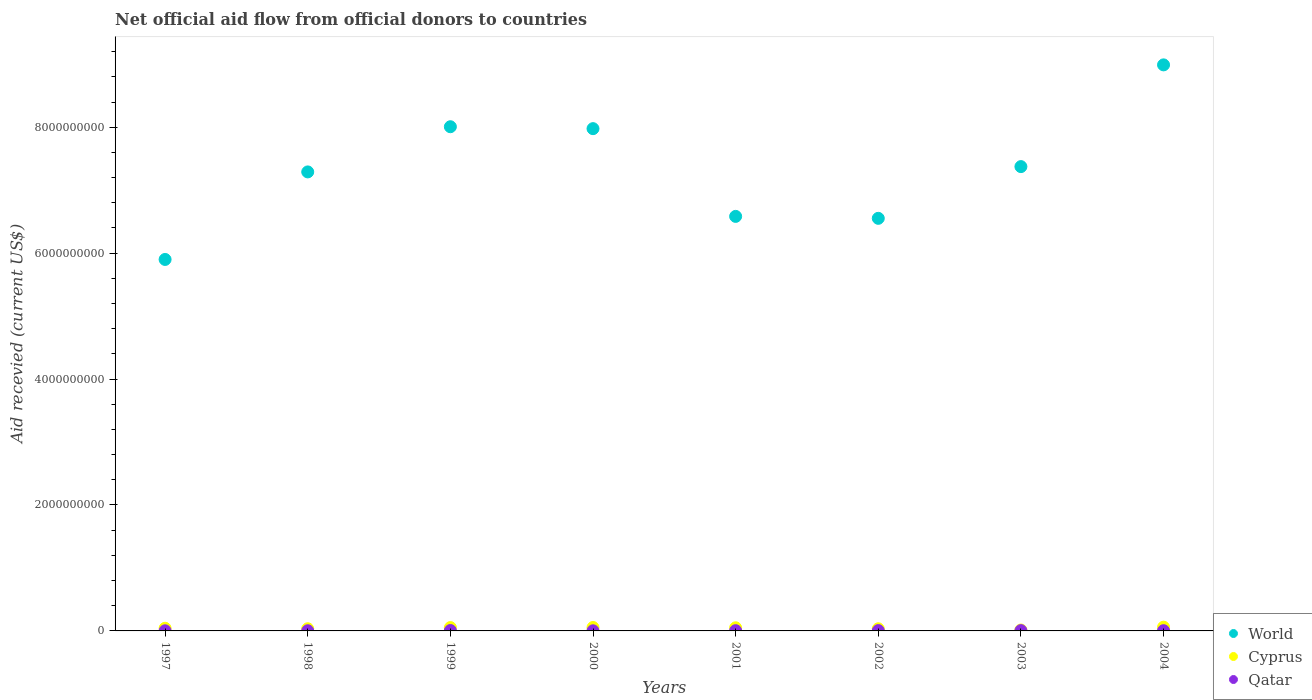How many different coloured dotlines are there?
Your answer should be compact. 3. What is the total aid received in Cyprus in 2004?
Offer a terse response. 5.99e+07. Across all years, what is the maximum total aid received in Qatar?
Offer a terse response. 6.34e+06. Across all years, what is the minimum total aid received in Qatar?
Provide a short and direct response. 1.94e+06. In which year was the total aid received in World maximum?
Give a very brief answer. 2004. What is the total total aid received in Qatar in the graph?
Make the answer very short. 3.04e+07. What is the difference between the total aid received in Qatar in 1997 and that in 1998?
Your response must be concise. -6.00e+05. What is the difference between the total aid received in Cyprus in 1999 and the total aid received in Qatar in 2000?
Your answer should be compact. 5.14e+07. What is the average total aid received in World per year?
Provide a succinct answer. 7.33e+09. In the year 2000, what is the difference between the total aid received in Qatar and total aid received in Cyprus?
Provide a succinct answer. -5.25e+07. What is the ratio of the total aid received in Qatar in 1999 to that in 2000?
Ensure brevity in your answer.  3.27. Is the difference between the total aid received in Qatar in 2002 and 2004 greater than the difference between the total aid received in Cyprus in 2002 and 2004?
Give a very brief answer. Yes. What is the difference between the highest and the second highest total aid received in Cyprus?
Your answer should be very brief. 5.46e+06. What is the difference between the highest and the lowest total aid received in Cyprus?
Provide a succinct answer. 4.55e+07. In how many years, is the total aid received in Qatar greater than the average total aid received in Qatar taken over all years?
Provide a short and direct response. 4. Is the sum of the total aid received in World in 2001 and 2002 greater than the maximum total aid received in Qatar across all years?
Keep it short and to the point. Yes. Does the total aid received in Cyprus monotonically increase over the years?
Make the answer very short. No. Is the total aid received in Qatar strictly greater than the total aid received in Cyprus over the years?
Your answer should be very brief. No. How many years are there in the graph?
Make the answer very short. 8. Are the values on the major ticks of Y-axis written in scientific E-notation?
Your answer should be compact. No. Does the graph contain any zero values?
Give a very brief answer. No. What is the title of the graph?
Your answer should be compact. Net official aid flow from official donors to countries. Does "Bermuda" appear as one of the legend labels in the graph?
Make the answer very short. No. What is the label or title of the X-axis?
Keep it short and to the point. Years. What is the label or title of the Y-axis?
Make the answer very short. Aid recevied (current US$). What is the Aid recevied (current US$) in World in 1997?
Provide a succinct answer. 5.90e+09. What is the Aid recevied (current US$) in Cyprus in 1997?
Offer a terse response. 4.22e+07. What is the Aid recevied (current US$) of Qatar in 1997?
Your answer should be compact. 2.06e+06. What is the Aid recevied (current US$) in World in 1998?
Offer a terse response. 7.29e+09. What is the Aid recevied (current US$) of Cyprus in 1998?
Keep it short and to the point. 3.45e+07. What is the Aid recevied (current US$) in Qatar in 1998?
Keep it short and to the point. 2.66e+06. What is the Aid recevied (current US$) of World in 1999?
Give a very brief answer. 8.01e+09. What is the Aid recevied (current US$) of Cyprus in 1999?
Your answer should be compact. 5.33e+07. What is the Aid recevied (current US$) of Qatar in 1999?
Your answer should be compact. 6.34e+06. What is the Aid recevied (current US$) in World in 2000?
Offer a very short reply. 7.98e+09. What is the Aid recevied (current US$) in Cyprus in 2000?
Provide a succinct answer. 5.44e+07. What is the Aid recevied (current US$) in Qatar in 2000?
Keep it short and to the point. 1.94e+06. What is the Aid recevied (current US$) of World in 2001?
Ensure brevity in your answer.  6.58e+09. What is the Aid recevied (current US$) in Cyprus in 2001?
Make the answer very short. 4.97e+07. What is the Aid recevied (current US$) of Qatar in 2001?
Offer a terse response. 3.91e+06. What is the Aid recevied (current US$) in World in 2002?
Keep it short and to the point. 6.55e+09. What is the Aid recevied (current US$) in Cyprus in 2002?
Your response must be concise. 3.42e+07. What is the Aid recevied (current US$) of Qatar in 2002?
Make the answer very short. 5.02e+06. What is the Aid recevied (current US$) of World in 2003?
Provide a short and direct response. 7.37e+09. What is the Aid recevied (current US$) in Cyprus in 2003?
Keep it short and to the point. 1.44e+07. What is the Aid recevied (current US$) in Qatar in 2003?
Keep it short and to the point. 4.82e+06. What is the Aid recevied (current US$) in World in 2004?
Make the answer very short. 8.99e+09. What is the Aid recevied (current US$) of Cyprus in 2004?
Your answer should be compact. 5.99e+07. What is the Aid recevied (current US$) of Qatar in 2004?
Your answer should be compact. 3.63e+06. Across all years, what is the maximum Aid recevied (current US$) of World?
Offer a very short reply. 8.99e+09. Across all years, what is the maximum Aid recevied (current US$) in Cyprus?
Your response must be concise. 5.99e+07. Across all years, what is the maximum Aid recevied (current US$) of Qatar?
Make the answer very short. 6.34e+06. Across all years, what is the minimum Aid recevied (current US$) in World?
Ensure brevity in your answer.  5.90e+09. Across all years, what is the minimum Aid recevied (current US$) in Cyprus?
Offer a very short reply. 1.44e+07. Across all years, what is the minimum Aid recevied (current US$) of Qatar?
Keep it short and to the point. 1.94e+06. What is the total Aid recevied (current US$) in World in the graph?
Provide a succinct answer. 5.87e+1. What is the total Aid recevied (current US$) of Cyprus in the graph?
Make the answer very short. 3.43e+08. What is the total Aid recevied (current US$) in Qatar in the graph?
Your response must be concise. 3.04e+07. What is the difference between the Aid recevied (current US$) in World in 1997 and that in 1998?
Give a very brief answer. -1.39e+09. What is the difference between the Aid recevied (current US$) in Cyprus in 1997 and that in 1998?
Give a very brief answer. 7.69e+06. What is the difference between the Aid recevied (current US$) in Qatar in 1997 and that in 1998?
Your answer should be compact. -6.00e+05. What is the difference between the Aid recevied (current US$) in World in 1997 and that in 1999?
Provide a succinct answer. -2.11e+09. What is the difference between the Aid recevied (current US$) of Cyprus in 1997 and that in 1999?
Your answer should be compact. -1.11e+07. What is the difference between the Aid recevied (current US$) in Qatar in 1997 and that in 1999?
Offer a very short reply. -4.28e+06. What is the difference between the Aid recevied (current US$) of World in 1997 and that in 2000?
Provide a short and direct response. -2.08e+09. What is the difference between the Aid recevied (current US$) in Cyprus in 1997 and that in 2000?
Give a very brief answer. -1.22e+07. What is the difference between the Aid recevied (current US$) of Qatar in 1997 and that in 2000?
Ensure brevity in your answer.  1.20e+05. What is the difference between the Aid recevied (current US$) of World in 1997 and that in 2001?
Your answer should be compact. -6.84e+08. What is the difference between the Aid recevied (current US$) of Cyprus in 1997 and that in 2001?
Provide a succinct answer. -7.48e+06. What is the difference between the Aid recevied (current US$) of Qatar in 1997 and that in 2001?
Your answer should be very brief. -1.85e+06. What is the difference between the Aid recevied (current US$) in World in 1997 and that in 2002?
Make the answer very short. -6.53e+08. What is the difference between the Aid recevied (current US$) in Cyprus in 1997 and that in 2002?
Your answer should be very brief. 7.97e+06. What is the difference between the Aid recevied (current US$) of Qatar in 1997 and that in 2002?
Keep it short and to the point. -2.96e+06. What is the difference between the Aid recevied (current US$) in World in 1997 and that in 2003?
Provide a succinct answer. -1.47e+09. What is the difference between the Aid recevied (current US$) of Cyprus in 1997 and that in 2003?
Your answer should be compact. 2.78e+07. What is the difference between the Aid recevied (current US$) in Qatar in 1997 and that in 2003?
Offer a terse response. -2.76e+06. What is the difference between the Aid recevied (current US$) of World in 1997 and that in 2004?
Provide a short and direct response. -3.09e+09. What is the difference between the Aid recevied (current US$) of Cyprus in 1997 and that in 2004?
Ensure brevity in your answer.  -1.76e+07. What is the difference between the Aid recevied (current US$) in Qatar in 1997 and that in 2004?
Provide a short and direct response. -1.57e+06. What is the difference between the Aid recevied (current US$) in World in 1998 and that in 1999?
Offer a terse response. -7.18e+08. What is the difference between the Aid recevied (current US$) of Cyprus in 1998 and that in 1999?
Provide a short and direct response. -1.88e+07. What is the difference between the Aid recevied (current US$) in Qatar in 1998 and that in 1999?
Your answer should be very brief. -3.68e+06. What is the difference between the Aid recevied (current US$) of World in 1998 and that in 2000?
Keep it short and to the point. -6.87e+08. What is the difference between the Aid recevied (current US$) of Cyprus in 1998 and that in 2000?
Ensure brevity in your answer.  -1.99e+07. What is the difference between the Aid recevied (current US$) of Qatar in 1998 and that in 2000?
Your answer should be very brief. 7.20e+05. What is the difference between the Aid recevied (current US$) in World in 1998 and that in 2001?
Make the answer very short. 7.06e+08. What is the difference between the Aid recevied (current US$) in Cyprus in 1998 and that in 2001?
Keep it short and to the point. -1.52e+07. What is the difference between the Aid recevied (current US$) in Qatar in 1998 and that in 2001?
Your answer should be very brief. -1.25e+06. What is the difference between the Aid recevied (current US$) in World in 1998 and that in 2002?
Keep it short and to the point. 7.37e+08. What is the difference between the Aid recevied (current US$) of Qatar in 1998 and that in 2002?
Your answer should be very brief. -2.36e+06. What is the difference between the Aid recevied (current US$) of World in 1998 and that in 2003?
Your answer should be very brief. -8.43e+07. What is the difference between the Aid recevied (current US$) in Cyprus in 1998 and that in 2003?
Offer a very short reply. 2.01e+07. What is the difference between the Aid recevied (current US$) of Qatar in 1998 and that in 2003?
Give a very brief answer. -2.16e+06. What is the difference between the Aid recevied (current US$) in World in 1998 and that in 2004?
Provide a short and direct response. -1.70e+09. What is the difference between the Aid recevied (current US$) of Cyprus in 1998 and that in 2004?
Provide a succinct answer. -2.53e+07. What is the difference between the Aid recevied (current US$) in Qatar in 1998 and that in 2004?
Your response must be concise. -9.70e+05. What is the difference between the Aid recevied (current US$) of World in 1999 and that in 2000?
Give a very brief answer. 3.04e+07. What is the difference between the Aid recevied (current US$) in Cyprus in 1999 and that in 2000?
Your answer should be compact. -1.09e+06. What is the difference between the Aid recevied (current US$) in Qatar in 1999 and that in 2000?
Your answer should be very brief. 4.40e+06. What is the difference between the Aid recevied (current US$) of World in 1999 and that in 2001?
Your response must be concise. 1.42e+09. What is the difference between the Aid recevied (current US$) of Cyprus in 1999 and that in 2001?
Keep it short and to the point. 3.61e+06. What is the difference between the Aid recevied (current US$) of Qatar in 1999 and that in 2001?
Your answer should be compact. 2.43e+06. What is the difference between the Aid recevied (current US$) of World in 1999 and that in 2002?
Your response must be concise. 1.45e+09. What is the difference between the Aid recevied (current US$) in Cyprus in 1999 and that in 2002?
Offer a very short reply. 1.91e+07. What is the difference between the Aid recevied (current US$) of Qatar in 1999 and that in 2002?
Your answer should be very brief. 1.32e+06. What is the difference between the Aid recevied (current US$) of World in 1999 and that in 2003?
Ensure brevity in your answer.  6.33e+08. What is the difference between the Aid recevied (current US$) of Cyprus in 1999 and that in 2003?
Make the answer very short. 3.89e+07. What is the difference between the Aid recevied (current US$) in Qatar in 1999 and that in 2003?
Keep it short and to the point. 1.52e+06. What is the difference between the Aid recevied (current US$) in World in 1999 and that in 2004?
Your answer should be very brief. -9.82e+08. What is the difference between the Aid recevied (current US$) in Cyprus in 1999 and that in 2004?
Your response must be concise. -6.55e+06. What is the difference between the Aid recevied (current US$) in Qatar in 1999 and that in 2004?
Your answer should be very brief. 2.71e+06. What is the difference between the Aid recevied (current US$) in World in 2000 and that in 2001?
Offer a very short reply. 1.39e+09. What is the difference between the Aid recevied (current US$) in Cyprus in 2000 and that in 2001?
Offer a very short reply. 4.70e+06. What is the difference between the Aid recevied (current US$) in Qatar in 2000 and that in 2001?
Make the answer very short. -1.97e+06. What is the difference between the Aid recevied (current US$) of World in 2000 and that in 2002?
Ensure brevity in your answer.  1.42e+09. What is the difference between the Aid recevied (current US$) in Cyprus in 2000 and that in 2002?
Your answer should be very brief. 2.02e+07. What is the difference between the Aid recevied (current US$) in Qatar in 2000 and that in 2002?
Offer a terse response. -3.08e+06. What is the difference between the Aid recevied (current US$) in World in 2000 and that in 2003?
Keep it short and to the point. 6.03e+08. What is the difference between the Aid recevied (current US$) in Cyprus in 2000 and that in 2003?
Provide a succinct answer. 4.00e+07. What is the difference between the Aid recevied (current US$) in Qatar in 2000 and that in 2003?
Keep it short and to the point. -2.88e+06. What is the difference between the Aid recevied (current US$) in World in 2000 and that in 2004?
Give a very brief answer. -1.01e+09. What is the difference between the Aid recevied (current US$) in Cyprus in 2000 and that in 2004?
Offer a very short reply. -5.46e+06. What is the difference between the Aid recevied (current US$) in Qatar in 2000 and that in 2004?
Your answer should be compact. -1.69e+06. What is the difference between the Aid recevied (current US$) in World in 2001 and that in 2002?
Make the answer very short. 3.09e+07. What is the difference between the Aid recevied (current US$) of Cyprus in 2001 and that in 2002?
Your answer should be very brief. 1.54e+07. What is the difference between the Aid recevied (current US$) of Qatar in 2001 and that in 2002?
Ensure brevity in your answer.  -1.11e+06. What is the difference between the Aid recevied (current US$) in World in 2001 and that in 2003?
Your answer should be compact. -7.91e+08. What is the difference between the Aid recevied (current US$) of Cyprus in 2001 and that in 2003?
Give a very brief answer. 3.53e+07. What is the difference between the Aid recevied (current US$) of Qatar in 2001 and that in 2003?
Give a very brief answer. -9.10e+05. What is the difference between the Aid recevied (current US$) of World in 2001 and that in 2004?
Your answer should be very brief. -2.41e+09. What is the difference between the Aid recevied (current US$) in Cyprus in 2001 and that in 2004?
Give a very brief answer. -1.02e+07. What is the difference between the Aid recevied (current US$) in Qatar in 2001 and that in 2004?
Give a very brief answer. 2.80e+05. What is the difference between the Aid recevied (current US$) in World in 2002 and that in 2003?
Offer a terse response. -8.22e+08. What is the difference between the Aid recevied (current US$) of Cyprus in 2002 and that in 2003?
Provide a succinct answer. 1.99e+07. What is the difference between the Aid recevied (current US$) in World in 2002 and that in 2004?
Your answer should be very brief. -2.44e+09. What is the difference between the Aid recevied (current US$) of Cyprus in 2002 and that in 2004?
Offer a very short reply. -2.56e+07. What is the difference between the Aid recevied (current US$) of Qatar in 2002 and that in 2004?
Your response must be concise. 1.39e+06. What is the difference between the Aid recevied (current US$) in World in 2003 and that in 2004?
Provide a short and direct response. -1.62e+09. What is the difference between the Aid recevied (current US$) of Cyprus in 2003 and that in 2004?
Your answer should be compact. -4.55e+07. What is the difference between the Aid recevied (current US$) in Qatar in 2003 and that in 2004?
Your response must be concise. 1.19e+06. What is the difference between the Aid recevied (current US$) in World in 1997 and the Aid recevied (current US$) in Cyprus in 1998?
Provide a succinct answer. 5.87e+09. What is the difference between the Aid recevied (current US$) of World in 1997 and the Aid recevied (current US$) of Qatar in 1998?
Your answer should be very brief. 5.90e+09. What is the difference between the Aid recevied (current US$) in Cyprus in 1997 and the Aid recevied (current US$) in Qatar in 1998?
Your answer should be very brief. 3.96e+07. What is the difference between the Aid recevied (current US$) in World in 1997 and the Aid recevied (current US$) in Cyprus in 1999?
Ensure brevity in your answer.  5.85e+09. What is the difference between the Aid recevied (current US$) of World in 1997 and the Aid recevied (current US$) of Qatar in 1999?
Your response must be concise. 5.89e+09. What is the difference between the Aid recevied (current US$) in Cyprus in 1997 and the Aid recevied (current US$) in Qatar in 1999?
Offer a very short reply. 3.59e+07. What is the difference between the Aid recevied (current US$) in World in 1997 and the Aid recevied (current US$) in Cyprus in 2000?
Your response must be concise. 5.85e+09. What is the difference between the Aid recevied (current US$) in World in 1997 and the Aid recevied (current US$) in Qatar in 2000?
Ensure brevity in your answer.  5.90e+09. What is the difference between the Aid recevied (current US$) of Cyprus in 1997 and the Aid recevied (current US$) of Qatar in 2000?
Make the answer very short. 4.03e+07. What is the difference between the Aid recevied (current US$) in World in 1997 and the Aid recevied (current US$) in Cyprus in 2001?
Your answer should be compact. 5.85e+09. What is the difference between the Aid recevied (current US$) in World in 1997 and the Aid recevied (current US$) in Qatar in 2001?
Give a very brief answer. 5.90e+09. What is the difference between the Aid recevied (current US$) in Cyprus in 1997 and the Aid recevied (current US$) in Qatar in 2001?
Offer a very short reply. 3.83e+07. What is the difference between the Aid recevied (current US$) in World in 1997 and the Aid recevied (current US$) in Cyprus in 2002?
Provide a short and direct response. 5.87e+09. What is the difference between the Aid recevied (current US$) of World in 1997 and the Aid recevied (current US$) of Qatar in 2002?
Make the answer very short. 5.89e+09. What is the difference between the Aid recevied (current US$) in Cyprus in 1997 and the Aid recevied (current US$) in Qatar in 2002?
Provide a short and direct response. 3.72e+07. What is the difference between the Aid recevied (current US$) of World in 1997 and the Aid recevied (current US$) of Cyprus in 2003?
Your answer should be compact. 5.89e+09. What is the difference between the Aid recevied (current US$) of World in 1997 and the Aid recevied (current US$) of Qatar in 2003?
Offer a terse response. 5.89e+09. What is the difference between the Aid recevied (current US$) of Cyprus in 1997 and the Aid recevied (current US$) of Qatar in 2003?
Ensure brevity in your answer.  3.74e+07. What is the difference between the Aid recevied (current US$) of World in 1997 and the Aid recevied (current US$) of Cyprus in 2004?
Your response must be concise. 5.84e+09. What is the difference between the Aid recevied (current US$) in World in 1997 and the Aid recevied (current US$) in Qatar in 2004?
Ensure brevity in your answer.  5.90e+09. What is the difference between the Aid recevied (current US$) in Cyprus in 1997 and the Aid recevied (current US$) in Qatar in 2004?
Make the answer very short. 3.86e+07. What is the difference between the Aid recevied (current US$) in World in 1998 and the Aid recevied (current US$) in Cyprus in 1999?
Keep it short and to the point. 7.24e+09. What is the difference between the Aid recevied (current US$) in World in 1998 and the Aid recevied (current US$) in Qatar in 1999?
Keep it short and to the point. 7.28e+09. What is the difference between the Aid recevied (current US$) in Cyprus in 1998 and the Aid recevied (current US$) in Qatar in 1999?
Your answer should be very brief. 2.82e+07. What is the difference between the Aid recevied (current US$) in World in 1998 and the Aid recevied (current US$) in Cyprus in 2000?
Your answer should be compact. 7.24e+09. What is the difference between the Aid recevied (current US$) in World in 1998 and the Aid recevied (current US$) in Qatar in 2000?
Offer a terse response. 7.29e+09. What is the difference between the Aid recevied (current US$) of Cyprus in 1998 and the Aid recevied (current US$) of Qatar in 2000?
Give a very brief answer. 3.26e+07. What is the difference between the Aid recevied (current US$) in World in 1998 and the Aid recevied (current US$) in Cyprus in 2001?
Give a very brief answer. 7.24e+09. What is the difference between the Aid recevied (current US$) in World in 1998 and the Aid recevied (current US$) in Qatar in 2001?
Ensure brevity in your answer.  7.29e+09. What is the difference between the Aid recevied (current US$) in Cyprus in 1998 and the Aid recevied (current US$) in Qatar in 2001?
Provide a succinct answer. 3.06e+07. What is the difference between the Aid recevied (current US$) of World in 1998 and the Aid recevied (current US$) of Cyprus in 2002?
Keep it short and to the point. 7.26e+09. What is the difference between the Aid recevied (current US$) of World in 1998 and the Aid recevied (current US$) of Qatar in 2002?
Ensure brevity in your answer.  7.29e+09. What is the difference between the Aid recevied (current US$) in Cyprus in 1998 and the Aid recevied (current US$) in Qatar in 2002?
Offer a very short reply. 2.95e+07. What is the difference between the Aid recevied (current US$) in World in 1998 and the Aid recevied (current US$) in Cyprus in 2003?
Your answer should be compact. 7.28e+09. What is the difference between the Aid recevied (current US$) of World in 1998 and the Aid recevied (current US$) of Qatar in 2003?
Make the answer very short. 7.29e+09. What is the difference between the Aid recevied (current US$) in Cyprus in 1998 and the Aid recevied (current US$) in Qatar in 2003?
Give a very brief answer. 2.97e+07. What is the difference between the Aid recevied (current US$) of World in 1998 and the Aid recevied (current US$) of Cyprus in 2004?
Your answer should be very brief. 7.23e+09. What is the difference between the Aid recevied (current US$) in World in 1998 and the Aid recevied (current US$) in Qatar in 2004?
Provide a short and direct response. 7.29e+09. What is the difference between the Aid recevied (current US$) in Cyprus in 1998 and the Aid recevied (current US$) in Qatar in 2004?
Provide a short and direct response. 3.09e+07. What is the difference between the Aid recevied (current US$) of World in 1999 and the Aid recevied (current US$) of Cyprus in 2000?
Offer a very short reply. 7.95e+09. What is the difference between the Aid recevied (current US$) in World in 1999 and the Aid recevied (current US$) in Qatar in 2000?
Keep it short and to the point. 8.01e+09. What is the difference between the Aid recevied (current US$) in Cyprus in 1999 and the Aid recevied (current US$) in Qatar in 2000?
Offer a terse response. 5.14e+07. What is the difference between the Aid recevied (current US$) in World in 1999 and the Aid recevied (current US$) in Cyprus in 2001?
Your answer should be very brief. 7.96e+09. What is the difference between the Aid recevied (current US$) in World in 1999 and the Aid recevied (current US$) in Qatar in 2001?
Give a very brief answer. 8.00e+09. What is the difference between the Aid recevied (current US$) in Cyprus in 1999 and the Aid recevied (current US$) in Qatar in 2001?
Your answer should be compact. 4.94e+07. What is the difference between the Aid recevied (current US$) in World in 1999 and the Aid recevied (current US$) in Cyprus in 2002?
Offer a terse response. 7.97e+09. What is the difference between the Aid recevied (current US$) in World in 1999 and the Aid recevied (current US$) in Qatar in 2002?
Provide a short and direct response. 8.00e+09. What is the difference between the Aid recevied (current US$) in Cyprus in 1999 and the Aid recevied (current US$) in Qatar in 2002?
Make the answer very short. 4.83e+07. What is the difference between the Aid recevied (current US$) of World in 1999 and the Aid recevied (current US$) of Cyprus in 2003?
Give a very brief answer. 7.99e+09. What is the difference between the Aid recevied (current US$) of World in 1999 and the Aid recevied (current US$) of Qatar in 2003?
Make the answer very short. 8.00e+09. What is the difference between the Aid recevied (current US$) of Cyprus in 1999 and the Aid recevied (current US$) of Qatar in 2003?
Keep it short and to the point. 4.85e+07. What is the difference between the Aid recevied (current US$) in World in 1999 and the Aid recevied (current US$) in Cyprus in 2004?
Provide a short and direct response. 7.95e+09. What is the difference between the Aid recevied (current US$) in World in 1999 and the Aid recevied (current US$) in Qatar in 2004?
Offer a very short reply. 8.00e+09. What is the difference between the Aid recevied (current US$) in Cyprus in 1999 and the Aid recevied (current US$) in Qatar in 2004?
Give a very brief answer. 4.97e+07. What is the difference between the Aid recevied (current US$) in World in 2000 and the Aid recevied (current US$) in Cyprus in 2001?
Your answer should be very brief. 7.93e+09. What is the difference between the Aid recevied (current US$) in World in 2000 and the Aid recevied (current US$) in Qatar in 2001?
Offer a very short reply. 7.97e+09. What is the difference between the Aid recevied (current US$) in Cyprus in 2000 and the Aid recevied (current US$) in Qatar in 2001?
Offer a very short reply. 5.05e+07. What is the difference between the Aid recevied (current US$) of World in 2000 and the Aid recevied (current US$) of Cyprus in 2002?
Provide a succinct answer. 7.94e+09. What is the difference between the Aid recevied (current US$) in World in 2000 and the Aid recevied (current US$) in Qatar in 2002?
Keep it short and to the point. 7.97e+09. What is the difference between the Aid recevied (current US$) in Cyprus in 2000 and the Aid recevied (current US$) in Qatar in 2002?
Provide a short and direct response. 4.94e+07. What is the difference between the Aid recevied (current US$) of World in 2000 and the Aid recevied (current US$) of Cyprus in 2003?
Make the answer very short. 7.96e+09. What is the difference between the Aid recevied (current US$) of World in 2000 and the Aid recevied (current US$) of Qatar in 2003?
Give a very brief answer. 7.97e+09. What is the difference between the Aid recevied (current US$) in Cyprus in 2000 and the Aid recevied (current US$) in Qatar in 2003?
Ensure brevity in your answer.  4.96e+07. What is the difference between the Aid recevied (current US$) in World in 2000 and the Aid recevied (current US$) in Cyprus in 2004?
Keep it short and to the point. 7.92e+09. What is the difference between the Aid recevied (current US$) of World in 2000 and the Aid recevied (current US$) of Qatar in 2004?
Provide a succinct answer. 7.97e+09. What is the difference between the Aid recevied (current US$) of Cyprus in 2000 and the Aid recevied (current US$) of Qatar in 2004?
Provide a succinct answer. 5.08e+07. What is the difference between the Aid recevied (current US$) in World in 2001 and the Aid recevied (current US$) in Cyprus in 2002?
Your answer should be compact. 6.55e+09. What is the difference between the Aid recevied (current US$) in World in 2001 and the Aid recevied (current US$) in Qatar in 2002?
Your answer should be compact. 6.58e+09. What is the difference between the Aid recevied (current US$) of Cyprus in 2001 and the Aid recevied (current US$) of Qatar in 2002?
Give a very brief answer. 4.47e+07. What is the difference between the Aid recevied (current US$) in World in 2001 and the Aid recevied (current US$) in Cyprus in 2003?
Keep it short and to the point. 6.57e+09. What is the difference between the Aid recevied (current US$) in World in 2001 and the Aid recevied (current US$) in Qatar in 2003?
Make the answer very short. 6.58e+09. What is the difference between the Aid recevied (current US$) in Cyprus in 2001 and the Aid recevied (current US$) in Qatar in 2003?
Your answer should be very brief. 4.49e+07. What is the difference between the Aid recevied (current US$) of World in 2001 and the Aid recevied (current US$) of Cyprus in 2004?
Provide a succinct answer. 6.52e+09. What is the difference between the Aid recevied (current US$) in World in 2001 and the Aid recevied (current US$) in Qatar in 2004?
Ensure brevity in your answer.  6.58e+09. What is the difference between the Aid recevied (current US$) in Cyprus in 2001 and the Aid recevied (current US$) in Qatar in 2004?
Your answer should be very brief. 4.61e+07. What is the difference between the Aid recevied (current US$) in World in 2002 and the Aid recevied (current US$) in Cyprus in 2003?
Your answer should be very brief. 6.54e+09. What is the difference between the Aid recevied (current US$) in World in 2002 and the Aid recevied (current US$) in Qatar in 2003?
Provide a succinct answer. 6.55e+09. What is the difference between the Aid recevied (current US$) in Cyprus in 2002 and the Aid recevied (current US$) in Qatar in 2003?
Offer a very short reply. 2.94e+07. What is the difference between the Aid recevied (current US$) of World in 2002 and the Aid recevied (current US$) of Cyprus in 2004?
Your answer should be compact. 6.49e+09. What is the difference between the Aid recevied (current US$) of World in 2002 and the Aid recevied (current US$) of Qatar in 2004?
Your answer should be compact. 6.55e+09. What is the difference between the Aid recevied (current US$) in Cyprus in 2002 and the Aid recevied (current US$) in Qatar in 2004?
Your response must be concise. 3.06e+07. What is the difference between the Aid recevied (current US$) of World in 2003 and the Aid recevied (current US$) of Cyprus in 2004?
Provide a succinct answer. 7.31e+09. What is the difference between the Aid recevied (current US$) in World in 2003 and the Aid recevied (current US$) in Qatar in 2004?
Your answer should be very brief. 7.37e+09. What is the difference between the Aid recevied (current US$) in Cyprus in 2003 and the Aid recevied (current US$) in Qatar in 2004?
Provide a short and direct response. 1.08e+07. What is the average Aid recevied (current US$) in World per year?
Offer a terse response. 7.33e+09. What is the average Aid recevied (current US$) in Cyprus per year?
Offer a very short reply. 4.28e+07. What is the average Aid recevied (current US$) in Qatar per year?
Offer a terse response. 3.80e+06. In the year 1997, what is the difference between the Aid recevied (current US$) of World and Aid recevied (current US$) of Cyprus?
Make the answer very short. 5.86e+09. In the year 1997, what is the difference between the Aid recevied (current US$) of World and Aid recevied (current US$) of Qatar?
Keep it short and to the point. 5.90e+09. In the year 1997, what is the difference between the Aid recevied (current US$) of Cyprus and Aid recevied (current US$) of Qatar?
Your response must be concise. 4.02e+07. In the year 1998, what is the difference between the Aid recevied (current US$) in World and Aid recevied (current US$) in Cyprus?
Your answer should be very brief. 7.26e+09. In the year 1998, what is the difference between the Aid recevied (current US$) in World and Aid recevied (current US$) in Qatar?
Your response must be concise. 7.29e+09. In the year 1998, what is the difference between the Aid recevied (current US$) in Cyprus and Aid recevied (current US$) in Qatar?
Keep it short and to the point. 3.19e+07. In the year 1999, what is the difference between the Aid recevied (current US$) of World and Aid recevied (current US$) of Cyprus?
Provide a short and direct response. 7.95e+09. In the year 1999, what is the difference between the Aid recevied (current US$) of World and Aid recevied (current US$) of Qatar?
Your answer should be very brief. 8.00e+09. In the year 1999, what is the difference between the Aid recevied (current US$) of Cyprus and Aid recevied (current US$) of Qatar?
Your response must be concise. 4.70e+07. In the year 2000, what is the difference between the Aid recevied (current US$) of World and Aid recevied (current US$) of Cyprus?
Offer a terse response. 7.92e+09. In the year 2000, what is the difference between the Aid recevied (current US$) of World and Aid recevied (current US$) of Qatar?
Offer a very short reply. 7.98e+09. In the year 2000, what is the difference between the Aid recevied (current US$) in Cyprus and Aid recevied (current US$) in Qatar?
Give a very brief answer. 5.25e+07. In the year 2001, what is the difference between the Aid recevied (current US$) in World and Aid recevied (current US$) in Cyprus?
Offer a very short reply. 6.53e+09. In the year 2001, what is the difference between the Aid recevied (current US$) in World and Aid recevied (current US$) in Qatar?
Provide a short and direct response. 6.58e+09. In the year 2001, what is the difference between the Aid recevied (current US$) in Cyprus and Aid recevied (current US$) in Qatar?
Provide a succinct answer. 4.58e+07. In the year 2002, what is the difference between the Aid recevied (current US$) of World and Aid recevied (current US$) of Cyprus?
Your response must be concise. 6.52e+09. In the year 2002, what is the difference between the Aid recevied (current US$) in World and Aid recevied (current US$) in Qatar?
Your answer should be compact. 6.55e+09. In the year 2002, what is the difference between the Aid recevied (current US$) of Cyprus and Aid recevied (current US$) of Qatar?
Offer a terse response. 2.92e+07. In the year 2003, what is the difference between the Aid recevied (current US$) of World and Aid recevied (current US$) of Cyprus?
Offer a very short reply. 7.36e+09. In the year 2003, what is the difference between the Aid recevied (current US$) of World and Aid recevied (current US$) of Qatar?
Ensure brevity in your answer.  7.37e+09. In the year 2003, what is the difference between the Aid recevied (current US$) of Cyprus and Aid recevied (current US$) of Qatar?
Provide a succinct answer. 9.57e+06. In the year 2004, what is the difference between the Aid recevied (current US$) in World and Aid recevied (current US$) in Cyprus?
Keep it short and to the point. 8.93e+09. In the year 2004, what is the difference between the Aid recevied (current US$) in World and Aid recevied (current US$) in Qatar?
Your answer should be very brief. 8.99e+09. In the year 2004, what is the difference between the Aid recevied (current US$) in Cyprus and Aid recevied (current US$) in Qatar?
Make the answer very short. 5.62e+07. What is the ratio of the Aid recevied (current US$) in World in 1997 to that in 1998?
Offer a very short reply. 0.81. What is the ratio of the Aid recevied (current US$) of Cyprus in 1997 to that in 1998?
Ensure brevity in your answer.  1.22. What is the ratio of the Aid recevied (current US$) in Qatar in 1997 to that in 1998?
Provide a succinct answer. 0.77. What is the ratio of the Aid recevied (current US$) of World in 1997 to that in 1999?
Make the answer very short. 0.74. What is the ratio of the Aid recevied (current US$) of Cyprus in 1997 to that in 1999?
Your answer should be very brief. 0.79. What is the ratio of the Aid recevied (current US$) in Qatar in 1997 to that in 1999?
Your answer should be compact. 0.32. What is the ratio of the Aid recevied (current US$) of World in 1997 to that in 2000?
Keep it short and to the point. 0.74. What is the ratio of the Aid recevied (current US$) of Cyprus in 1997 to that in 2000?
Offer a terse response. 0.78. What is the ratio of the Aid recevied (current US$) of Qatar in 1997 to that in 2000?
Offer a very short reply. 1.06. What is the ratio of the Aid recevied (current US$) in World in 1997 to that in 2001?
Make the answer very short. 0.9. What is the ratio of the Aid recevied (current US$) of Cyprus in 1997 to that in 2001?
Your answer should be compact. 0.85. What is the ratio of the Aid recevied (current US$) in Qatar in 1997 to that in 2001?
Offer a terse response. 0.53. What is the ratio of the Aid recevied (current US$) in World in 1997 to that in 2002?
Offer a terse response. 0.9. What is the ratio of the Aid recevied (current US$) in Cyprus in 1997 to that in 2002?
Give a very brief answer. 1.23. What is the ratio of the Aid recevied (current US$) of Qatar in 1997 to that in 2002?
Make the answer very short. 0.41. What is the ratio of the Aid recevied (current US$) in World in 1997 to that in 2003?
Provide a short and direct response. 0.8. What is the ratio of the Aid recevied (current US$) in Cyprus in 1997 to that in 2003?
Your answer should be compact. 2.93. What is the ratio of the Aid recevied (current US$) of Qatar in 1997 to that in 2003?
Provide a short and direct response. 0.43. What is the ratio of the Aid recevied (current US$) in World in 1997 to that in 2004?
Make the answer very short. 0.66. What is the ratio of the Aid recevied (current US$) in Cyprus in 1997 to that in 2004?
Your response must be concise. 0.71. What is the ratio of the Aid recevied (current US$) in Qatar in 1997 to that in 2004?
Provide a succinct answer. 0.57. What is the ratio of the Aid recevied (current US$) in World in 1998 to that in 1999?
Offer a very short reply. 0.91. What is the ratio of the Aid recevied (current US$) of Cyprus in 1998 to that in 1999?
Keep it short and to the point. 0.65. What is the ratio of the Aid recevied (current US$) in Qatar in 1998 to that in 1999?
Provide a succinct answer. 0.42. What is the ratio of the Aid recevied (current US$) of World in 1998 to that in 2000?
Ensure brevity in your answer.  0.91. What is the ratio of the Aid recevied (current US$) in Cyprus in 1998 to that in 2000?
Your answer should be compact. 0.63. What is the ratio of the Aid recevied (current US$) in Qatar in 1998 to that in 2000?
Your answer should be compact. 1.37. What is the ratio of the Aid recevied (current US$) in World in 1998 to that in 2001?
Make the answer very short. 1.11. What is the ratio of the Aid recevied (current US$) of Cyprus in 1998 to that in 2001?
Offer a terse response. 0.69. What is the ratio of the Aid recevied (current US$) in Qatar in 1998 to that in 2001?
Ensure brevity in your answer.  0.68. What is the ratio of the Aid recevied (current US$) of World in 1998 to that in 2002?
Keep it short and to the point. 1.11. What is the ratio of the Aid recevied (current US$) of Cyprus in 1998 to that in 2002?
Your answer should be very brief. 1.01. What is the ratio of the Aid recevied (current US$) of Qatar in 1998 to that in 2002?
Keep it short and to the point. 0.53. What is the ratio of the Aid recevied (current US$) of World in 1998 to that in 2003?
Ensure brevity in your answer.  0.99. What is the ratio of the Aid recevied (current US$) of Cyprus in 1998 to that in 2003?
Keep it short and to the point. 2.4. What is the ratio of the Aid recevied (current US$) in Qatar in 1998 to that in 2003?
Keep it short and to the point. 0.55. What is the ratio of the Aid recevied (current US$) of World in 1998 to that in 2004?
Make the answer very short. 0.81. What is the ratio of the Aid recevied (current US$) in Cyprus in 1998 to that in 2004?
Provide a short and direct response. 0.58. What is the ratio of the Aid recevied (current US$) of Qatar in 1998 to that in 2004?
Keep it short and to the point. 0.73. What is the ratio of the Aid recevied (current US$) of Qatar in 1999 to that in 2000?
Your answer should be compact. 3.27. What is the ratio of the Aid recevied (current US$) in World in 1999 to that in 2001?
Provide a succinct answer. 1.22. What is the ratio of the Aid recevied (current US$) in Cyprus in 1999 to that in 2001?
Offer a terse response. 1.07. What is the ratio of the Aid recevied (current US$) of Qatar in 1999 to that in 2001?
Offer a terse response. 1.62. What is the ratio of the Aid recevied (current US$) in World in 1999 to that in 2002?
Offer a terse response. 1.22. What is the ratio of the Aid recevied (current US$) in Cyprus in 1999 to that in 2002?
Offer a terse response. 1.56. What is the ratio of the Aid recevied (current US$) in Qatar in 1999 to that in 2002?
Offer a very short reply. 1.26. What is the ratio of the Aid recevied (current US$) of World in 1999 to that in 2003?
Your answer should be very brief. 1.09. What is the ratio of the Aid recevied (current US$) of Cyprus in 1999 to that in 2003?
Keep it short and to the point. 3.7. What is the ratio of the Aid recevied (current US$) of Qatar in 1999 to that in 2003?
Make the answer very short. 1.32. What is the ratio of the Aid recevied (current US$) in World in 1999 to that in 2004?
Offer a terse response. 0.89. What is the ratio of the Aid recevied (current US$) in Cyprus in 1999 to that in 2004?
Make the answer very short. 0.89. What is the ratio of the Aid recevied (current US$) in Qatar in 1999 to that in 2004?
Provide a succinct answer. 1.75. What is the ratio of the Aid recevied (current US$) of World in 2000 to that in 2001?
Provide a short and direct response. 1.21. What is the ratio of the Aid recevied (current US$) of Cyprus in 2000 to that in 2001?
Keep it short and to the point. 1.09. What is the ratio of the Aid recevied (current US$) of Qatar in 2000 to that in 2001?
Provide a succinct answer. 0.5. What is the ratio of the Aid recevied (current US$) in World in 2000 to that in 2002?
Give a very brief answer. 1.22. What is the ratio of the Aid recevied (current US$) in Cyprus in 2000 to that in 2002?
Your answer should be very brief. 1.59. What is the ratio of the Aid recevied (current US$) in Qatar in 2000 to that in 2002?
Give a very brief answer. 0.39. What is the ratio of the Aid recevied (current US$) of World in 2000 to that in 2003?
Offer a terse response. 1.08. What is the ratio of the Aid recevied (current US$) in Cyprus in 2000 to that in 2003?
Your response must be concise. 3.78. What is the ratio of the Aid recevied (current US$) in Qatar in 2000 to that in 2003?
Your answer should be compact. 0.4. What is the ratio of the Aid recevied (current US$) of World in 2000 to that in 2004?
Offer a terse response. 0.89. What is the ratio of the Aid recevied (current US$) of Cyprus in 2000 to that in 2004?
Provide a succinct answer. 0.91. What is the ratio of the Aid recevied (current US$) of Qatar in 2000 to that in 2004?
Offer a terse response. 0.53. What is the ratio of the Aid recevied (current US$) in World in 2001 to that in 2002?
Provide a short and direct response. 1. What is the ratio of the Aid recevied (current US$) of Cyprus in 2001 to that in 2002?
Your answer should be compact. 1.45. What is the ratio of the Aid recevied (current US$) of Qatar in 2001 to that in 2002?
Give a very brief answer. 0.78. What is the ratio of the Aid recevied (current US$) of World in 2001 to that in 2003?
Keep it short and to the point. 0.89. What is the ratio of the Aid recevied (current US$) of Cyprus in 2001 to that in 2003?
Ensure brevity in your answer.  3.45. What is the ratio of the Aid recevied (current US$) of Qatar in 2001 to that in 2003?
Make the answer very short. 0.81. What is the ratio of the Aid recevied (current US$) in World in 2001 to that in 2004?
Your response must be concise. 0.73. What is the ratio of the Aid recevied (current US$) of Cyprus in 2001 to that in 2004?
Give a very brief answer. 0.83. What is the ratio of the Aid recevied (current US$) of Qatar in 2001 to that in 2004?
Give a very brief answer. 1.08. What is the ratio of the Aid recevied (current US$) in World in 2002 to that in 2003?
Your response must be concise. 0.89. What is the ratio of the Aid recevied (current US$) in Cyprus in 2002 to that in 2003?
Ensure brevity in your answer.  2.38. What is the ratio of the Aid recevied (current US$) of Qatar in 2002 to that in 2003?
Your response must be concise. 1.04. What is the ratio of the Aid recevied (current US$) of World in 2002 to that in 2004?
Make the answer very short. 0.73. What is the ratio of the Aid recevied (current US$) in Cyprus in 2002 to that in 2004?
Make the answer very short. 0.57. What is the ratio of the Aid recevied (current US$) of Qatar in 2002 to that in 2004?
Make the answer very short. 1.38. What is the ratio of the Aid recevied (current US$) in World in 2003 to that in 2004?
Make the answer very short. 0.82. What is the ratio of the Aid recevied (current US$) in Cyprus in 2003 to that in 2004?
Your answer should be compact. 0.24. What is the ratio of the Aid recevied (current US$) in Qatar in 2003 to that in 2004?
Keep it short and to the point. 1.33. What is the difference between the highest and the second highest Aid recevied (current US$) in World?
Your response must be concise. 9.82e+08. What is the difference between the highest and the second highest Aid recevied (current US$) of Cyprus?
Your answer should be very brief. 5.46e+06. What is the difference between the highest and the second highest Aid recevied (current US$) in Qatar?
Offer a terse response. 1.32e+06. What is the difference between the highest and the lowest Aid recevied (current US$) of World?
Make the answer very short. 3.09e+09. What is the difference between the highest and the lowest Aid recevied (current US$) of Cyprus?
Offer a very short reply. 4.55e+07. What is the difference between the highest and the lowest Aid recevied (current US$) of Qatar?
Your answer should be compact. 4.40e+06. 